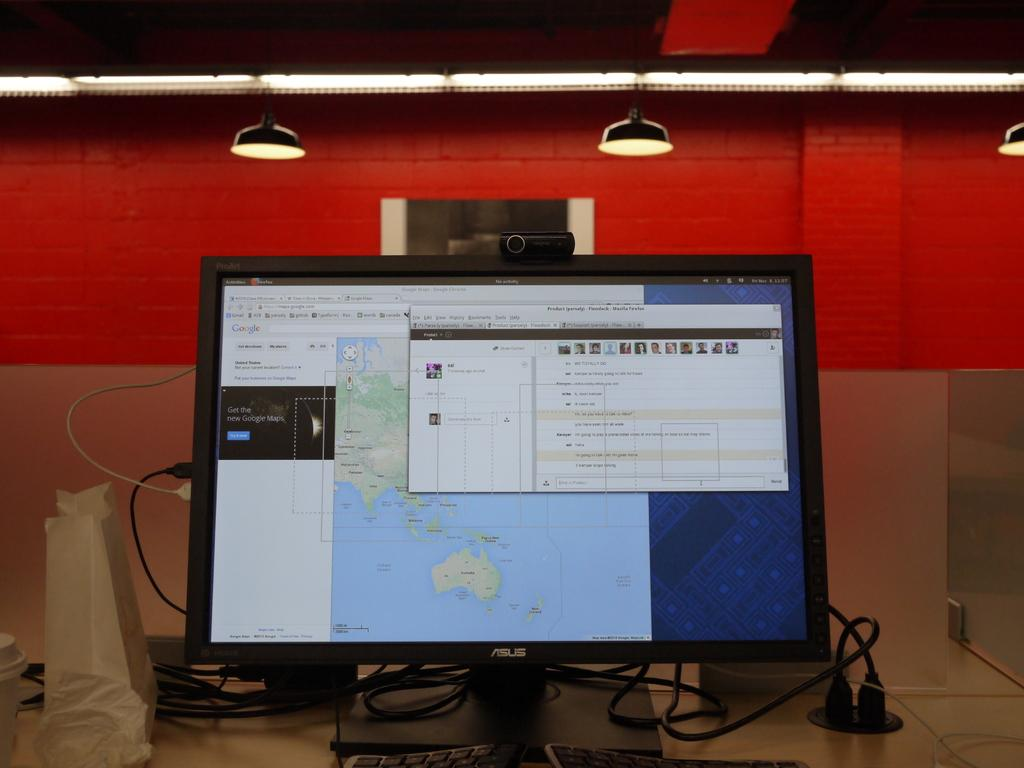<image>
Create a compact narrative representing the image presented. An Asus computer monitor has three windows open on the screen. 